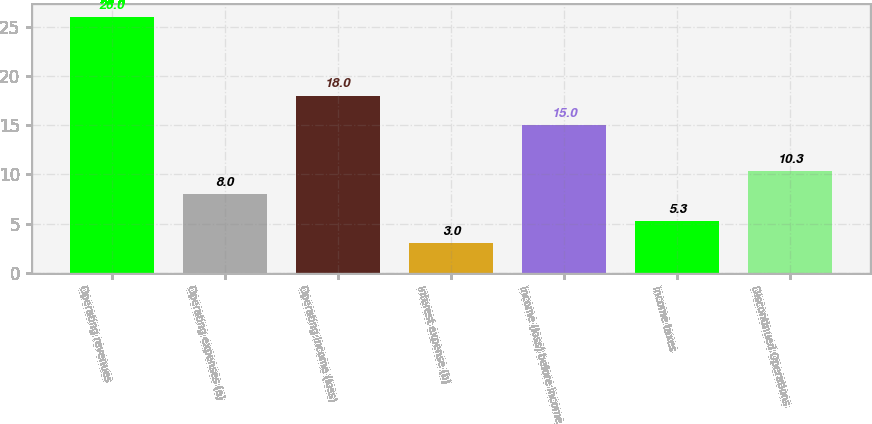<chart> <loc_0><loc_0><loc_500><loc_500><bar_chart><fcel>Operating revenues<fcel>Operating expenses (a)<fcel>Operating income (loss)<fcel>Interest expense (b)<fcel>Income (loss) before income<fcel>Income taxes<fcel>Discontinued Operations<nl><fcel>26<fcel>8<fcel>18<fcel>3<fcel>15<fcel>5.3<fcel>10.3<nl></chart> 